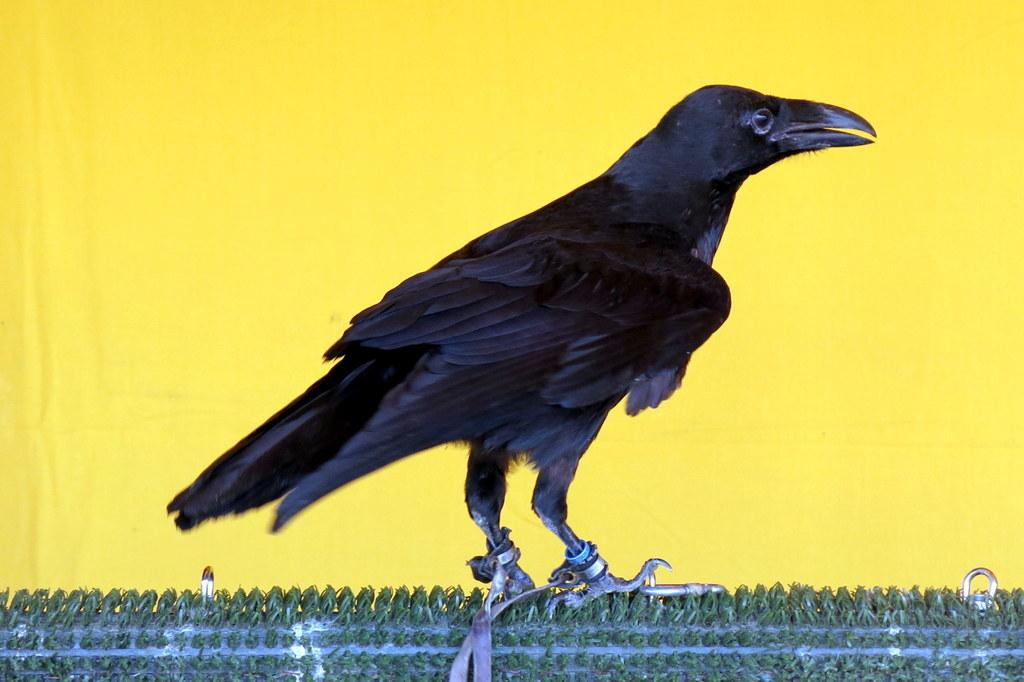What type of bird is in the image? There is a black color bird in the image. What is the bird standing on? The bird is on a green color surface. What color is the background of the image? The background of the image is yellow in color. What type of cord is being used by the bird in the image? There is no cord present in the image; the bird is simply standing on a green color surface. 